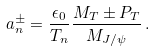Convert formula to latex. <formula><loc_0><loc_0><loc_500><loc_500>a _ { n } ^ { \pm } = \frac { \epsilon _ { 0 } } { T _ { n } } \frac { M _ { T } \pm P _ { T } } { M _ { J / \psi } } \, .</formula> 